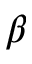<formula> <loc_0><loc_0><loc_500><loc_500>\beta</formula> 